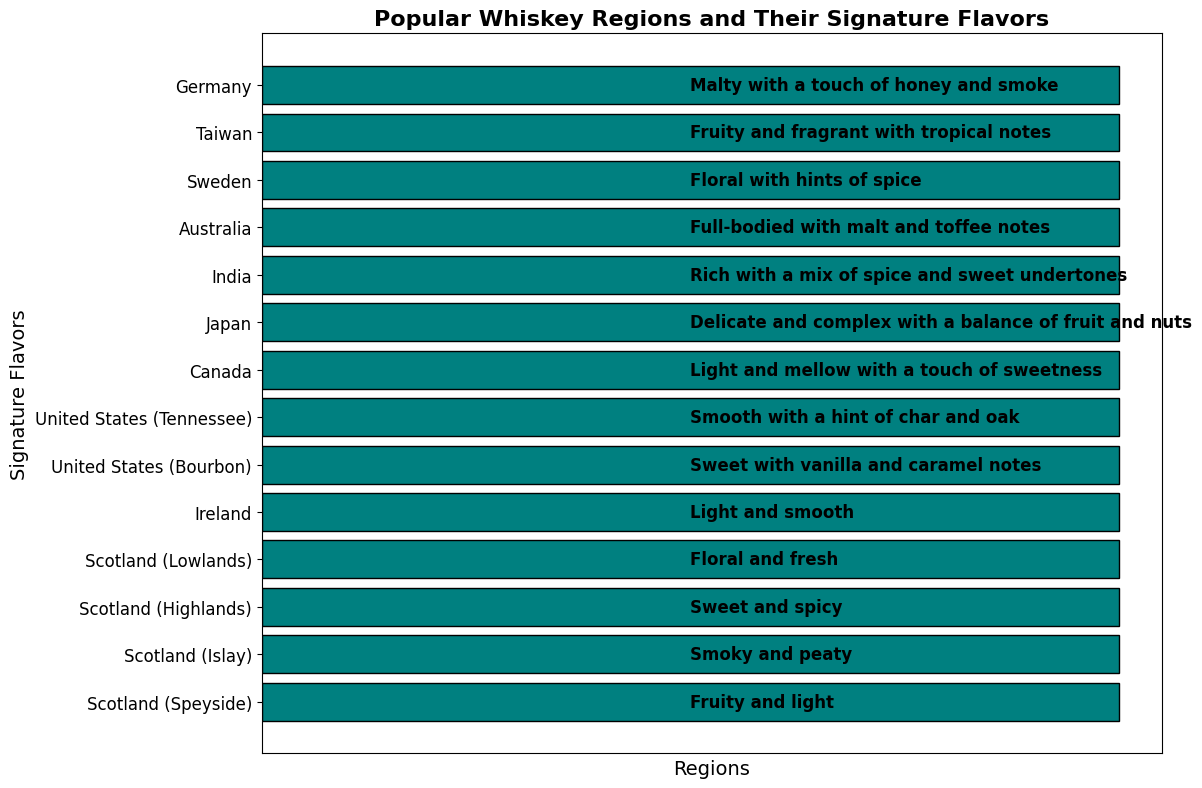What is the signature flavor of whiskey from Ireland? The signature flavor of whiskey from Ireland is given directly in the chart; you just need to look at the region "Ireland" and read the corresponding flavor description.
Answer: Light and smooth Which regions are described as having a "light" signature flavor? To determine which regions have a "light" signature flavor, look for the term "light" in the flavor descriptions. The regions with "light" in their description are "Scotland (Speyside)," "Ireland," and "Canada."
Answer: Scotland (Speyside), Ireland, Canada Compare the whiskey flavors between Scotland (Islay) and Scotland (Speyside). Which region has a smoky flavor? Look at the flavor descriptions for both regions. "Scotland (Islay)" has a "Smoky and peaty" flavor, whereas "Scotland (Speyside)" has a "Fruity and light" flavor, indicating that Islay has the smoky flavor.
Answer: Scotland (Islay) Which countries have whiskey described as "floral"? Identify regions where the flavor description includes "floral." Both "Scotland (Lowlands)" and "Sweden" are described as having floral characteristics.
Answer: Scotland (Lowlands), Sweden How many regions have a signature flavor that includes a "fruity" note? Count the number of regions with "fruity" in their flavor descriptions. The regions with fruity notes are "Scotland (Speyside)," "Taiwan," and "Japan." Therefore, there are three such regions.
Answer: 3 What is the signature flavor of whiskey from the United States (Bourbon)? Look at the flavor description corresponding to "United States (Bourbon)" on the chart. The signature flavor is "Sweet with vanilla and caramel notes."
Answer: Sweet with vanilla and caramel notes Is the Canadian whiskey flavor description more similar to Irish or Tennessee whiskey, and why? Compare the flavor descriptions: Canada ("Light and mellow with a touch of sweetness"), Ireland ("Light and smooth"), and Tennessee ("Smooth with a hint of char and oak"). The Canadian description is closer to the Irish description due to the shared "light" and smooth/mellow aspects.
Answer: Irish whiskey Of the listed whiskey regions, which ones have a "spicy" component in their signature flavor? Identify the regions where the flavor description includes the word "spicy." The regions with a spicy component are "Scotland (Highlands)" and "Sweden."
Answer: Scotland (Highlands), Sweden Which whiskey flavor can be considered the most complex and why? Among the listed descriptions, "Japan" has a signature flavor described as "Delicate and complex with a balance of fruit and nuts," specifically indicating complexity.
Answer: Japan 